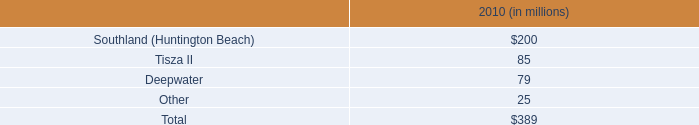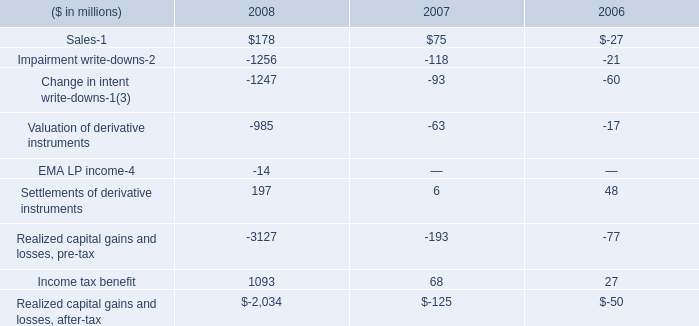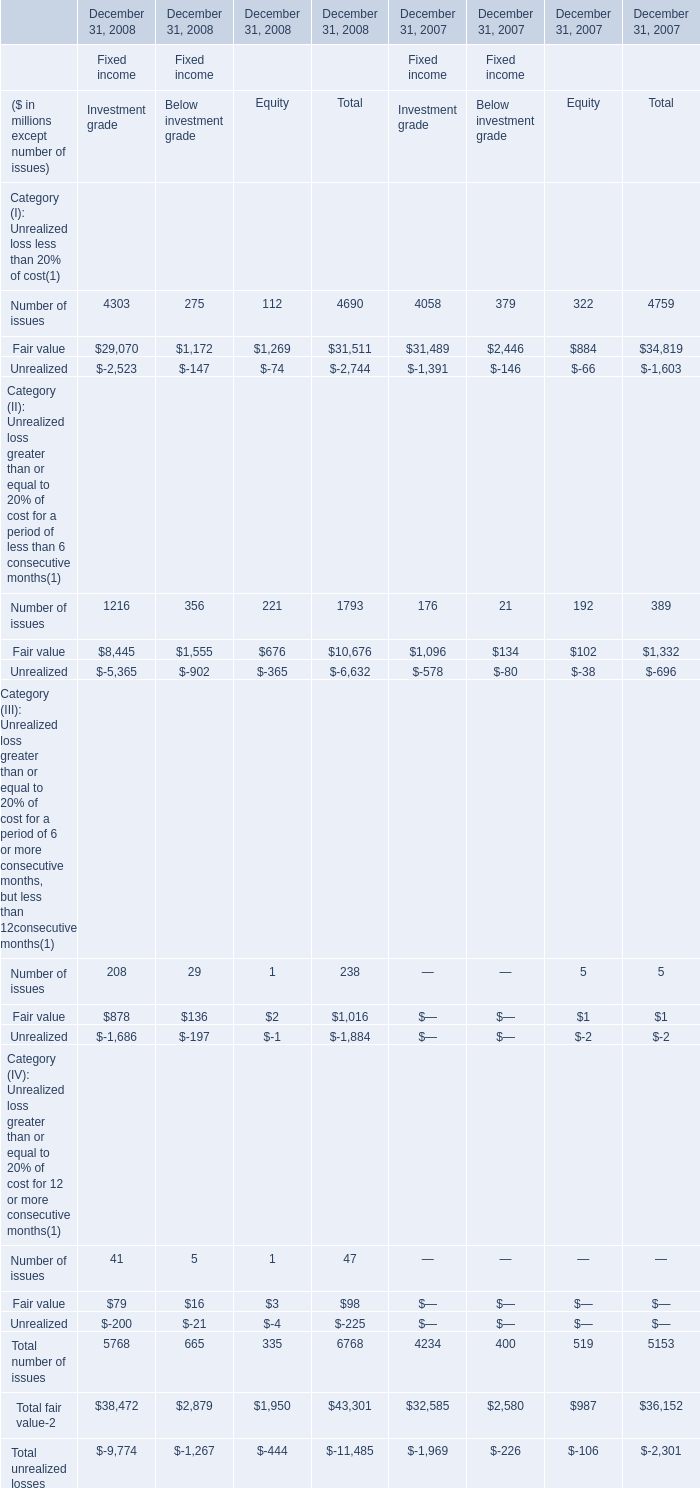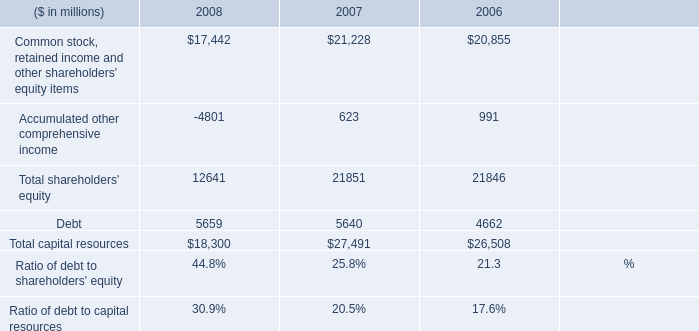What was the average of the Number of issues in the years where Number of issues is positive? (in million) 
Computations: ((1216 + 176) / 2)
Answer: 696.0. 